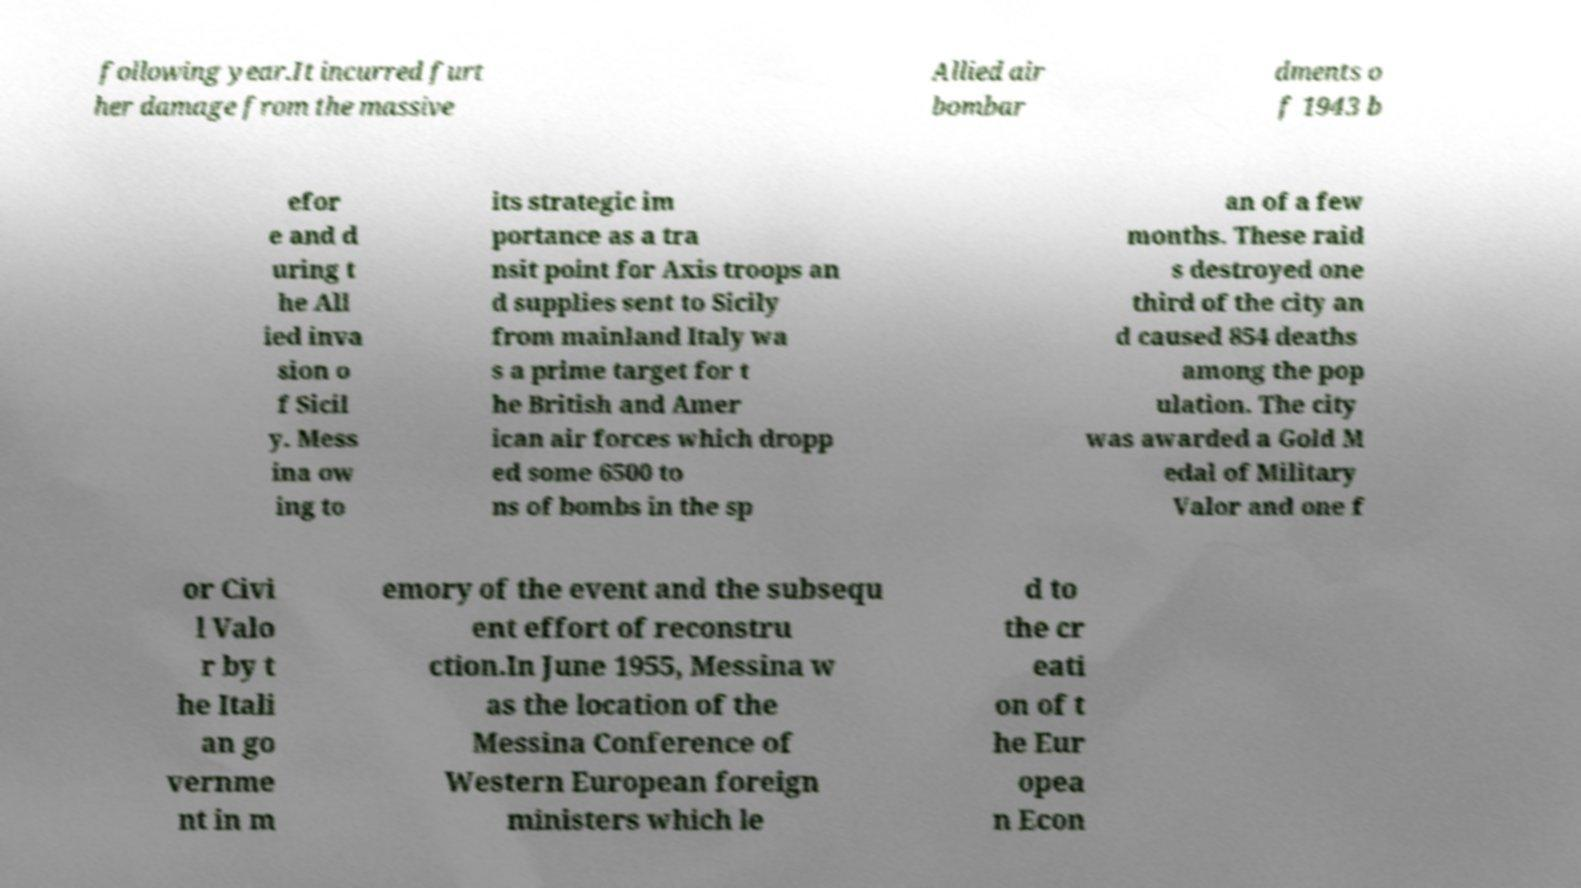There's text embedded in this image that I need extracted. Can you transcribe it verbatim? following year.It incurred furt her damage from the massive Allied air bombar dments o f 1943 b efor e and d uring t he All ied inva sion o f Sicil y. Mess ina ow ing to its strategic im portance as a tra nsit point for Axis troops an d supplies sent to Sicily from mainland Italy wa s a prime target for t he British and Amer ican air forces which dropp ed some 6500 to ns of bombs in the sp an of a few months. These raid s destroyed one third of the city an d caused 854 deaths among the pop ulation. The city was awarded a Gold M edal of Military Valor and one f or Civi l Valo r by t he Itali an go vernme nt in m emory of the event and the subsequ ent effort of reconstru ction.In June 1955, Messina w as the location of the Messina Conference of Western European foreign ministers which le d to the cr eati on of t he Eur opea n Econ 